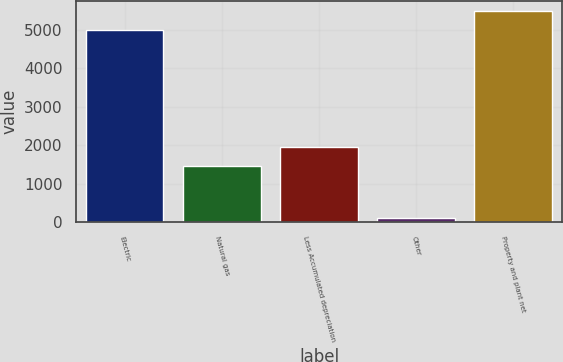Convert chart to OTSL. <chart><loc_0><loc_0><loc_500><loc_500><bar_chart><fcel>Electric<fcel>Natural gas<fcel>Less Accumulated depreciation<fcel>Other<fcel>Property and plant net<nl><fcel>4985<fcel>1461<fcel>1956.1<fcel>101<fcel>5480.1<nl></chart> 